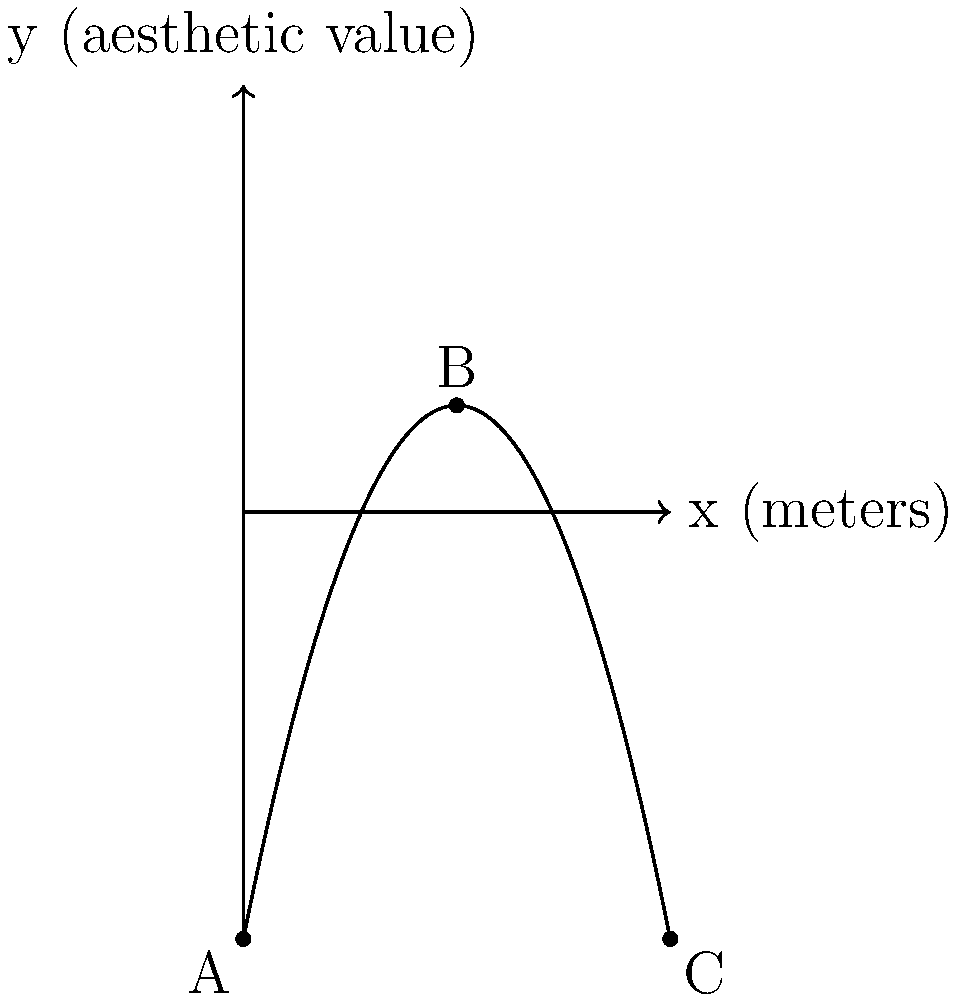An interior designer wants to place a piece of artwork along a wall in a room. The aesthetic value of the artwork's placement can be modeled by the quadratic function $f(x) = -0.5x^2 + 5x - 10$, where $x$ is the distance in meters from the left edge of the wall, and $f(x)$ represents the aesthetic value. What is the optimal distance $x$ from the left edge to place the artwork to maximize its aesthetic value? To find the optimal placement of the artwork, we need to determine the maximum point of the quadratic function. This can be done by following these steps:

1) The general form of a quadratic function is $f(x) = ax^2 + bx + c$. In this case:
   $a = -0.5$, $b = 5$, and $c = -10$

2) For a quadratic function, the x-coordinate of the vertex (which represents the maximum point for a downward-facing parabola) is given by the formula: $x = -\frac{b}{2a}$

3) Substituting our values:
   $x = -\frac{5}{2(-0.5)} = -\frac{5}{-1} = 5$

4) Therefore, the optimal distance from the left edge of the wall is 5 meters.

5) We can verify this by calculating the y-value at this point:
   $f(5) = -0.5(5)^2 + 5(5) - 10 = -12.5 + 25 - 10 = 2.5$

This is indeed the highest point on the parabola, as shown in the graph.
Answer: 5 meters 